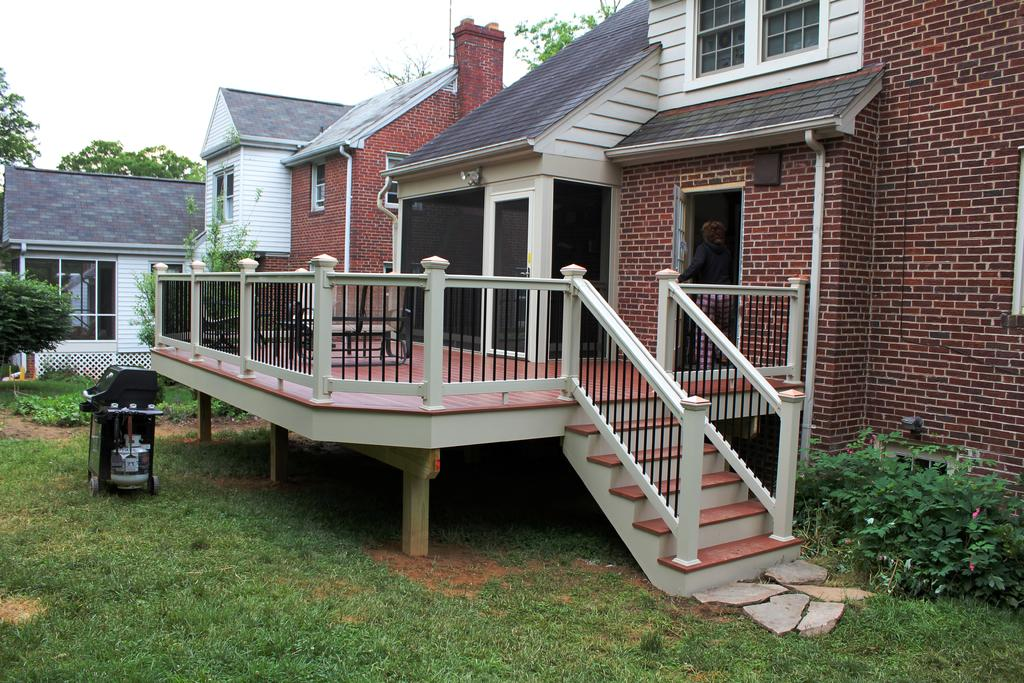What type of structures can be seen in the image? There are houses in the image. Can you identify any living beings in the image? Yes, there is a person in the image. What type of vegetation is present in the image? There is grass in the image. What other object can be seen in the image? There is a plant in the image. What might be used for waste disposal in the image? There is a bin in the image. What type of stamp can be seen on the person's forehead in the image? There is no stamp present on the person's forehead in the image. What type of system is the person using to communicate with the houses in the image? There is no system for communication between the person and the houses in the image. 